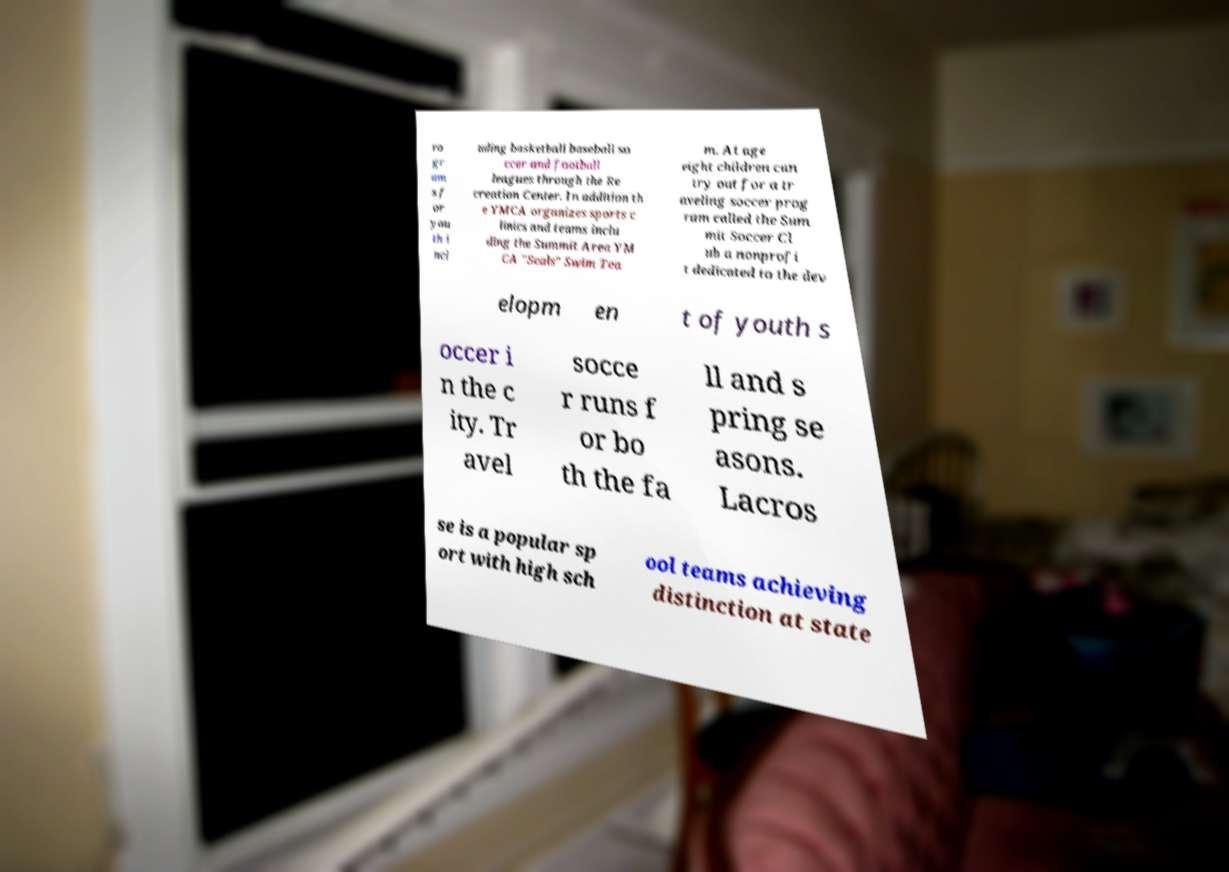I need the written content from this picture converted into text. Can you do that? ro gr am s f or you th i ncl uding basketball baseball so ccer and football leagues through the Re creation Center. In addition th e YMCA organizes sports c linics and teams inclu ding the Summit Area YM CA "Seals" Swim Tea m. At age eight children can try out for a tr aveling soccer prog ram called the Sum mit Soccer Cl ub a nonprofi t dedicated to the dev elopm en t of youth s occer i n the c ity. Tr avel socce r runs f or bo th the fa ll and s pring se asons. Lacros se is a popular sp ort with high sch ool teams achieving distinction at state 